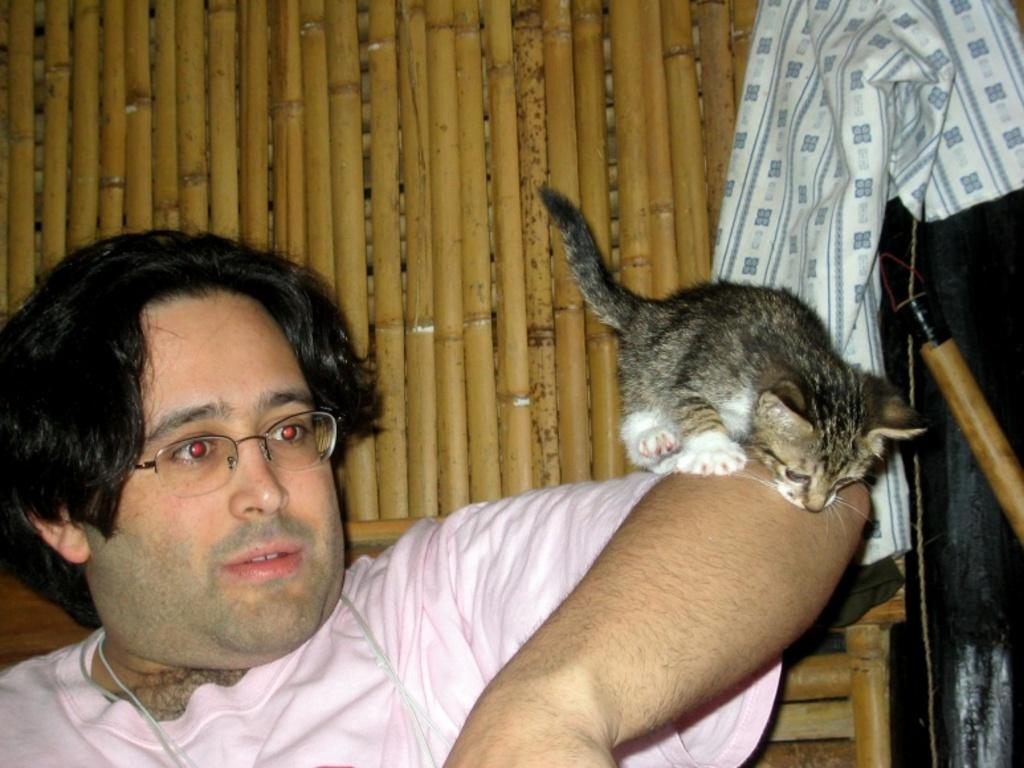What is the person in the image doing? The person is sitting on a chair in the image. What is the person holding in the image? The person is holding a cat in the image. What can be seen in the background of the image? There is a wood wall and cloth visible in the background of the image. What type of calculator is the person using in the image? There is no calculator present in the image. How many hands does the cat have in the image? Cats have four legs, but they are not referred to as hands. The cat in the image has paws, not hands. 